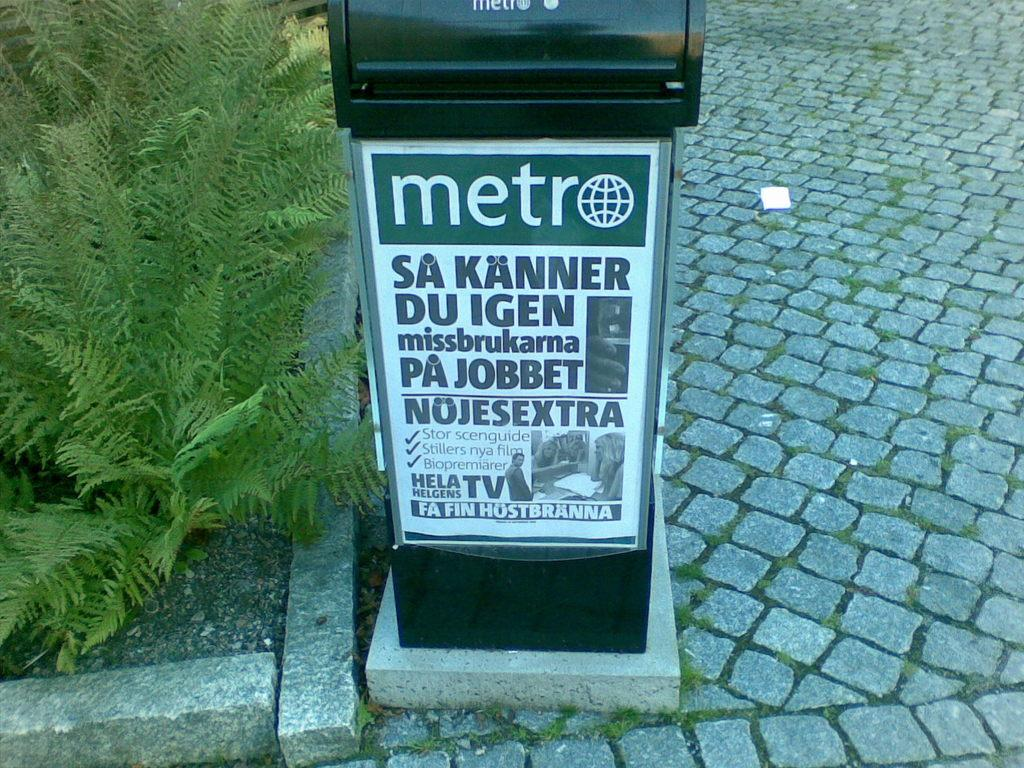<image>
Share a concise interpretation of the image provided. Sign on a green object which says "METRO". 